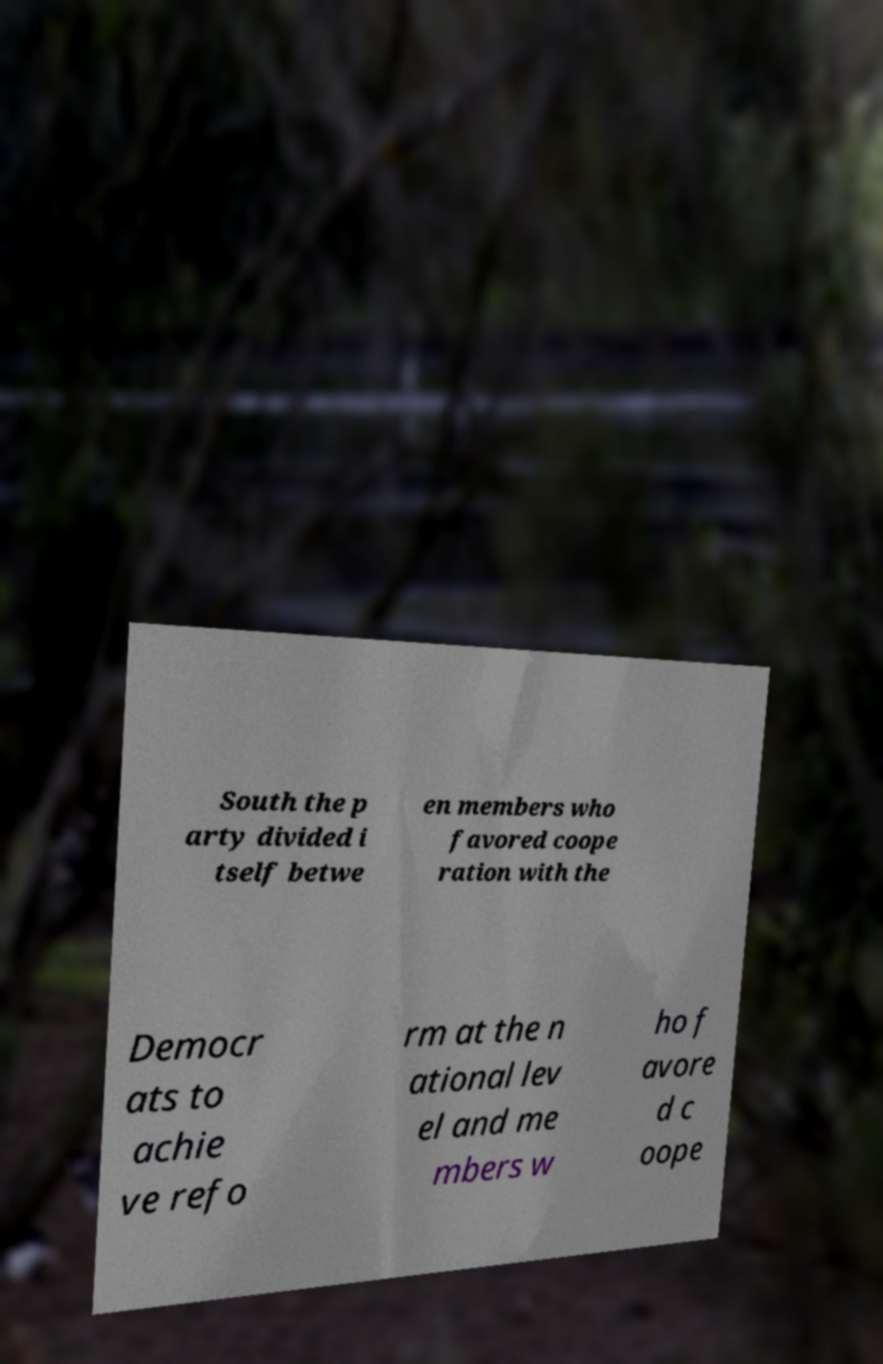Can you accurately transcribe the text from the provided image for me? South the p arty divided i tself betwe en members who favored coope ration with the Democr ats to achie ve refo rm at the n ational lev el and me mbers w ho f avore d c oope 